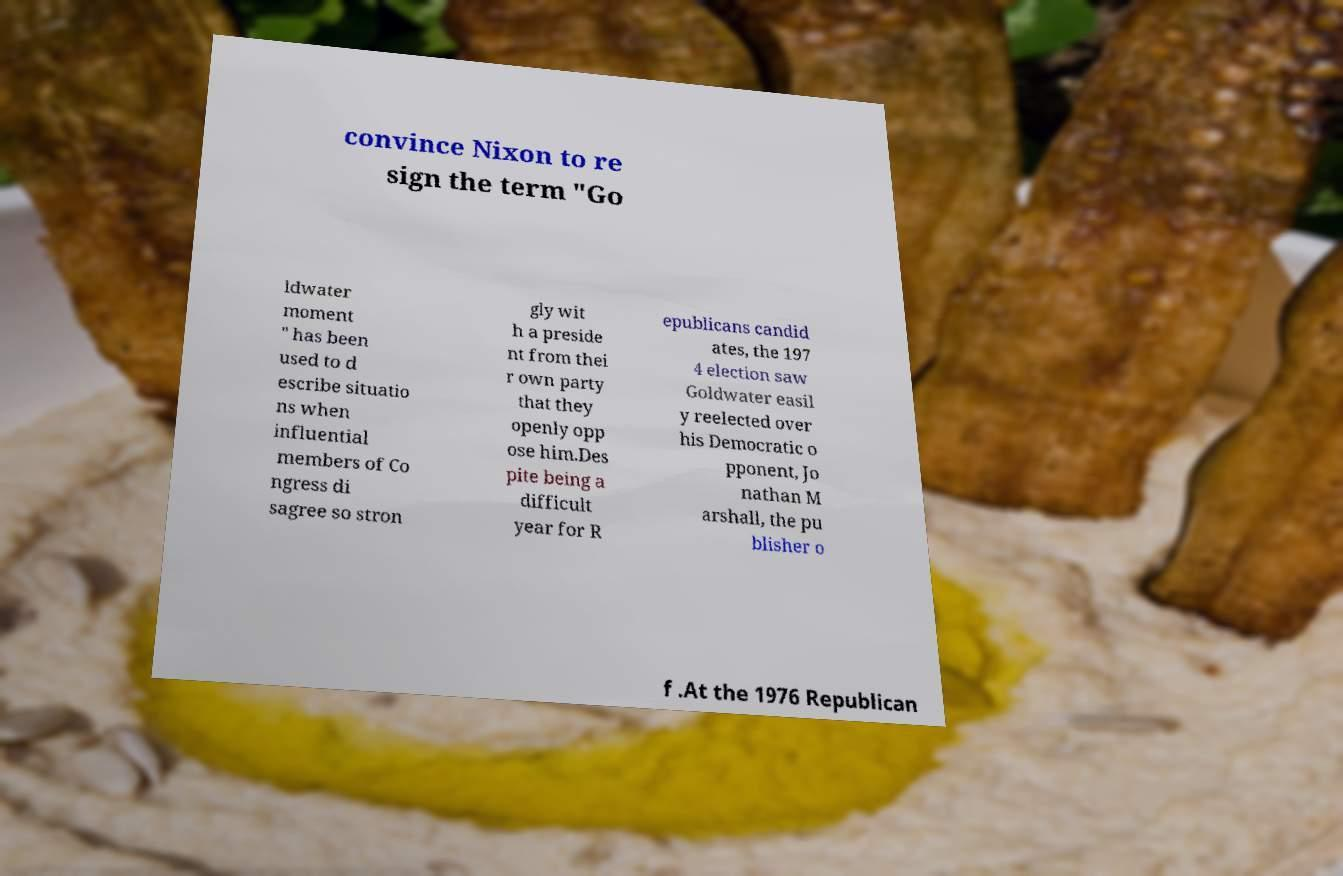Can you accurately transcribe the text from the provided image for me? convince Nixon to re sign the term "Go ldwater moment " has been used to d escribe situatio ns when influential members of Co ngress di sagree so stron gly wit h a preside nt from thei r own party that they openly opp ose him.Des pite being a difficult year for R epublicans candid ates, the 197 4 election saw Goldwater easil y reelected over his Democratic o pponent, Jo nathan M arshall, the pu blisher o f .At the 1976 Republican 